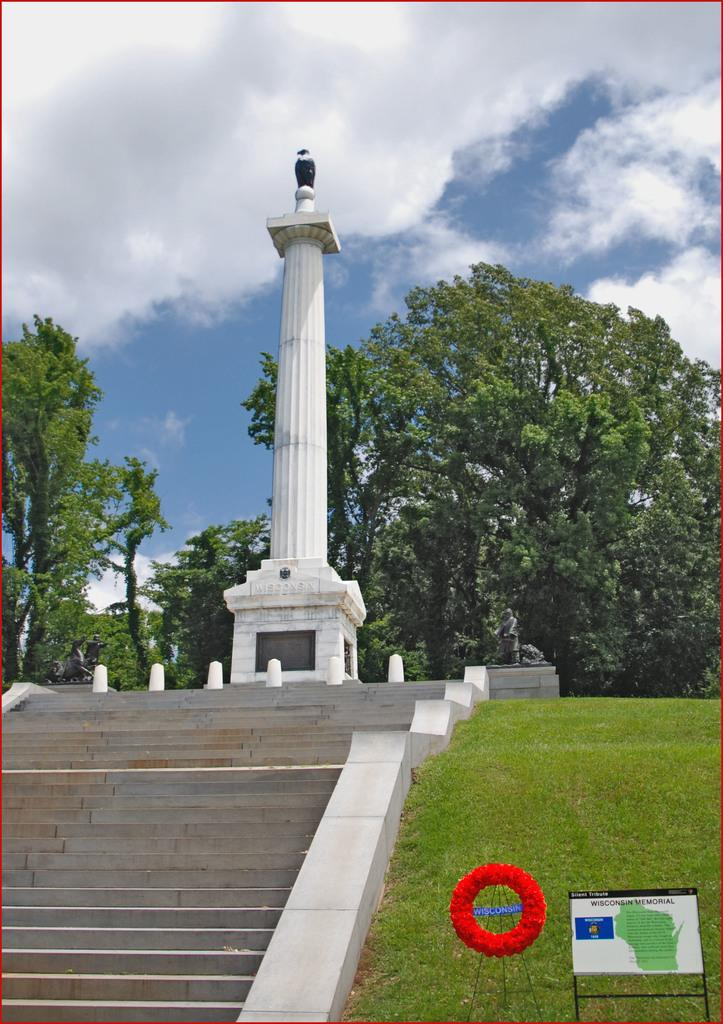What structure is located on the left side of the image? There is a staircase on the left side of the image. What can be seen in the middle of the image? There is a white pillar in the middle of the image. What type of natural elements are visible in the image? There are trees visible in the image. What is the condition of the sky in the image? The sky is cloudy in the image. How many dogs are present in the image? There are no dogs present in the image. What type of representative can be seen in the image? There is no representative present in the image. 